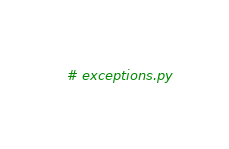<code> <loc_0><loc_0><loc_500><loc_500><_Python_># exceptions.py</code> 